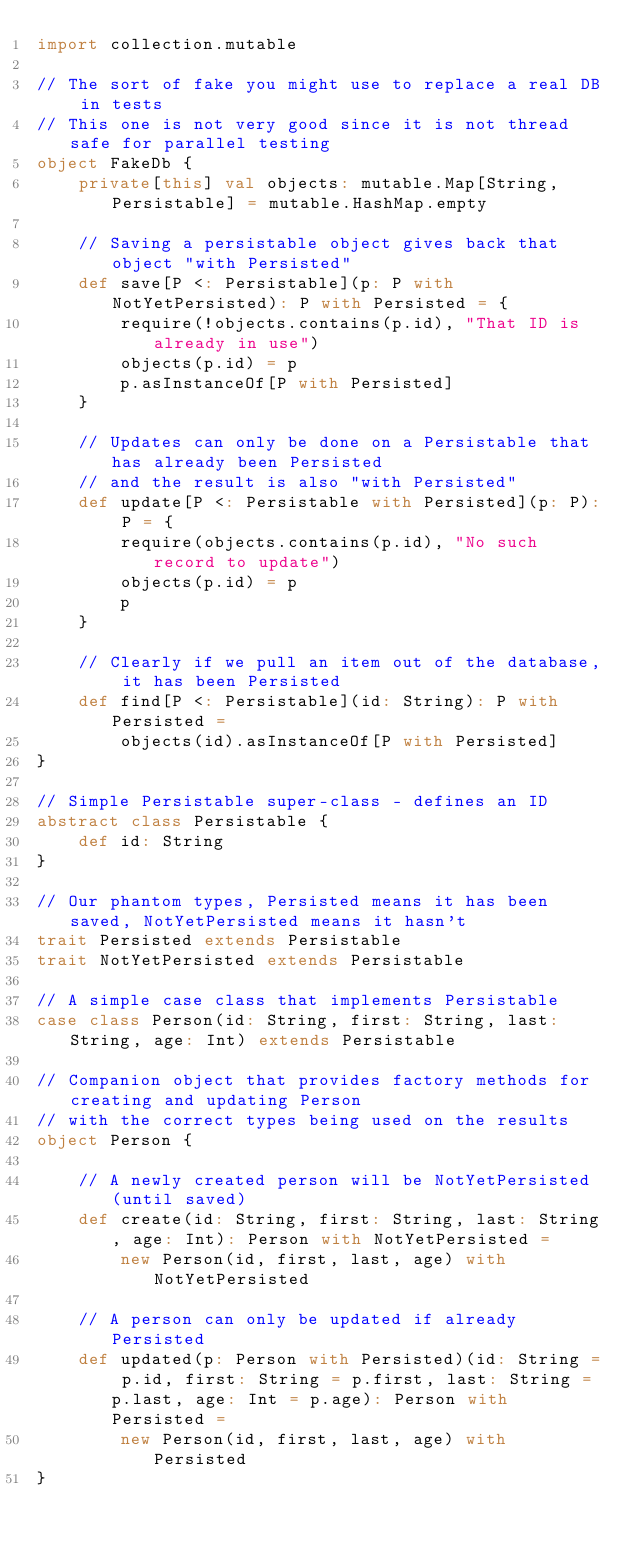<code> <loc_0><loc_0><loc_500><loc_500><_Scala_>import collection.mutable

// The sort of fake you might use to replace a real DB in tests
// This one is not very good since it is not thread safe for parallel testing
object FakeDb {
    private[this] val objects: mutable.Map[String, Persistable] = mutable.HashMap.empty
    
    // Saving a persistable object gives back that object "with Persisted"
    def save[P <: Persistable](p: P with NotYetPersisted): P with Persisted = {
        require(!objects.contains(p.id), "That ID is already in use")
        objects(p.id) = p
        p.asInstanceOf[P with Persisted]
    }
    
    // Updates can only be done on a Persistable that has already been Persisted
    // and the result is also "with Persisted"
    def update[P <: Persistable with Persisted](p: P): P = {
        require(objects.contains(p.id), "No such record to update")
        objects(p.id) = p
        p
    }
    
    // Clearly if we pull an item out of the database, it has been Persisted
    def find[P <: Persistable](id: String): P with Persisted =
        objects(id).asInstanceOf[P with Persisted]
}

// Simple Persistable super-class - defines an ID
abstract class Persistable {
    def id: String
}

// Our phantom types, Persisted means it has been saved, NotYetPersisted means it hasn't
trait Persisted extends Persistable
trait NotYetPersisted extends Persistable

// A simple case class that implements Persistable
case class Person(id: String, first: String, last: String, age: Int) extends Persistable

// Companion object that provides factory methods for creating and updating Person
// with the correct types being used on the results
object Person {
    
    // A newly created person will be NotYetPersisted (until saved)
    def create(id: String, first: String, last: String, age: Int): Person with NotYetPersisted = 
        new Person(id, first, last, age) with NotYetPersisted
    
    // A person can only be updated if already Persisted
    def updated(p: Person with Persisted)(id: String = p.id, first: String = p.first, last: String = p.last, age: Int = p.age): Person with Persisted =
        new Person(id, first, last, age) with Persisted
}</code> 